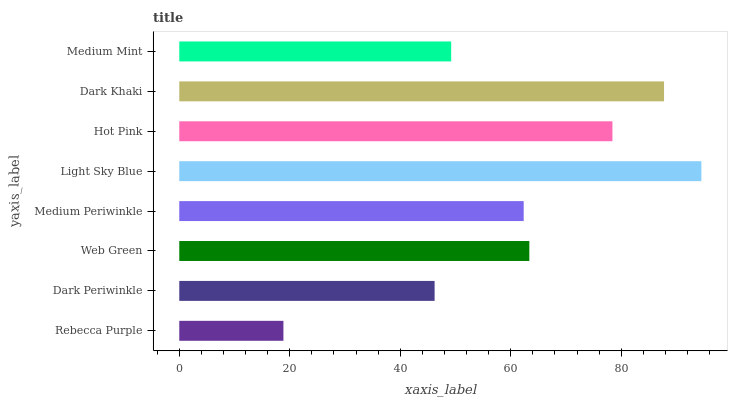Is Rebecca Purple the minimum?
Answer yes or no. Yes. Is Light Sky Blue the maximum?
Answer yes or no. Yes. Is Dark Periwinkle the minimum?
Answer yes or no. No. Is Dark Periwinkle the maximum?
Answer yes or no. No. Is Dark Periwinkle greater than Rebecca Purple?
Answer yes or no. Yes. Is Rebecca Purple less than Dark Periwinkle?
Answer yes or no. Yes. Is Rebecca Purple greater than Dark Periwinkle?
Answer yes or no. No. Is Dark Periwinkle less than Rebecca Purple?
Answer yes or no. No. Is Web Green the high median?
Answer yes or no. Yes. Is Medium Periwinkle the low median?
Answer yes or no. Yes. Is Hot Pink the high median?
Answer yes or no. No. Is Medium Mint the low median?
Answer yes or no. No. 